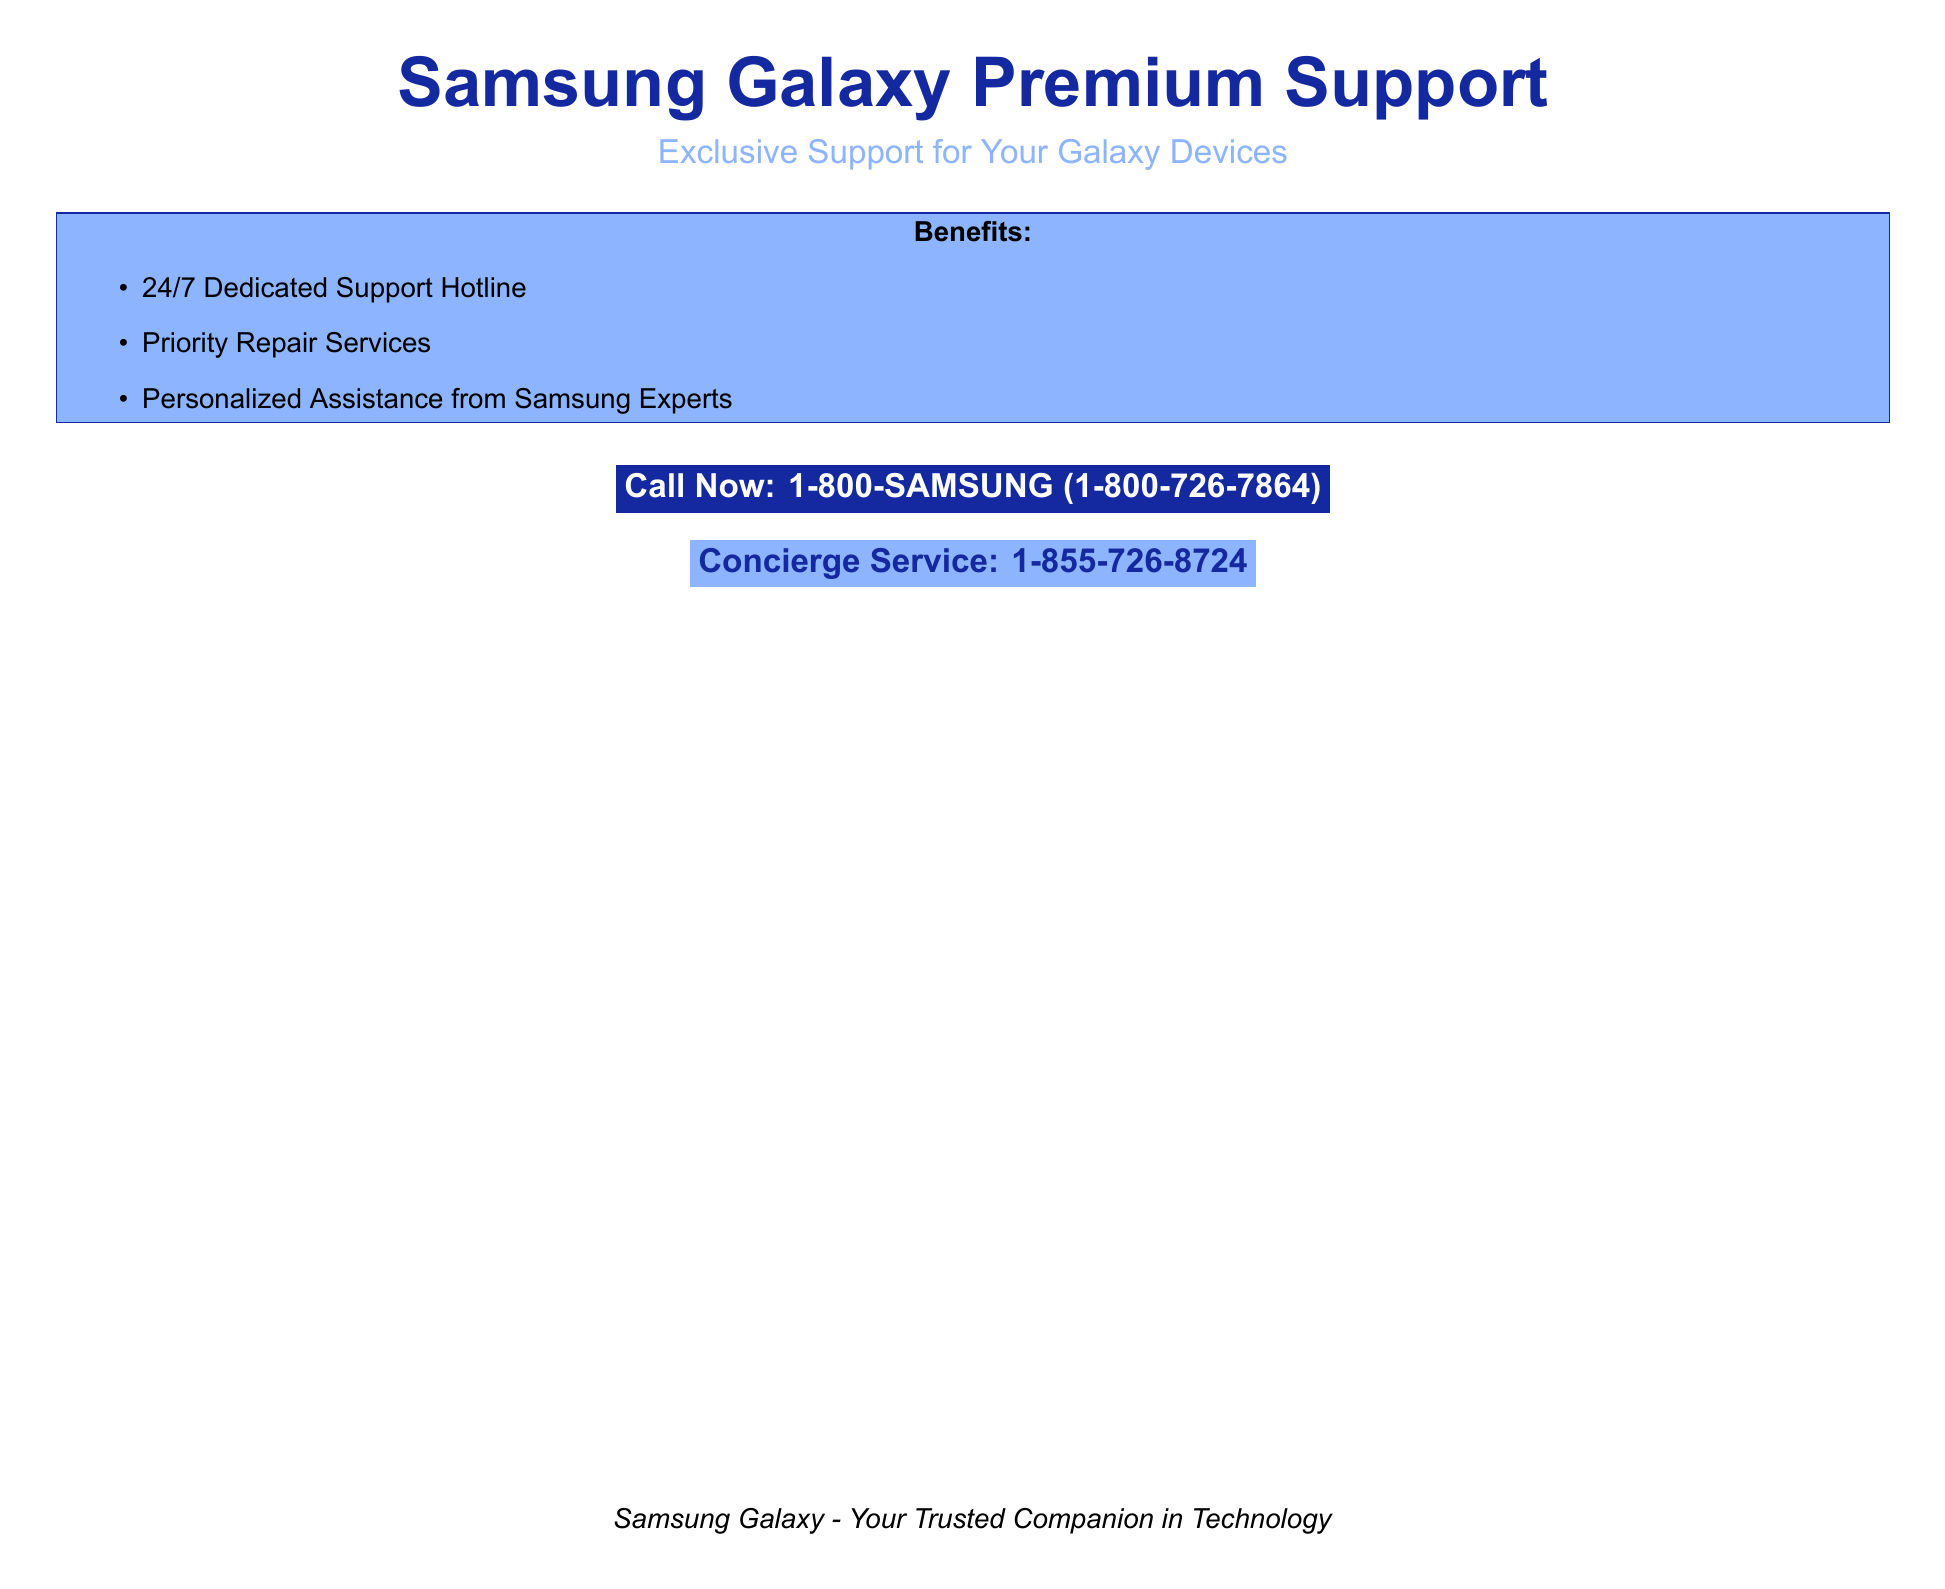What is the main title of the document? The main title is prominently displayed at the top of the document.
Answer: Samsung Galaxy Premium Support What is the support hotline number? The support hotline number is clearly stated in a highlighted box.
Answer: 1-800-SAMSUNG (1-800-726-7864) What services are listed as benefits? The benefits are listed in a bullet point format within a colored box.
Answer: 24/7 Dedicated Support Hotline, Priority Repair Services, Personalized Assistance from Samsung Experts What is the concierge service number? The concierge service number is listed in a separate colored box at the bottom.
Answer: 1-855-726-8724 How many benefits are mentioned in the document? The number of benefits can be counted from the bulleted list provided.
Answer: Three 